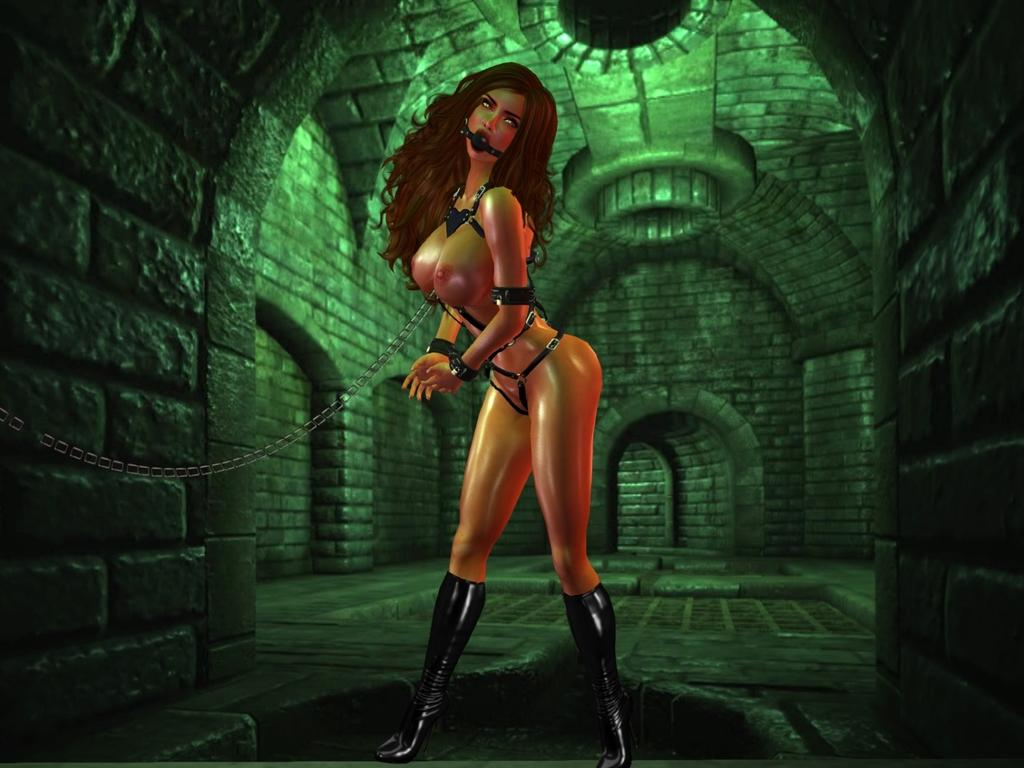Who is present in the image? There is a woman in the image. What is the woman's condition in the image? The woman is tied up with a chain in the image. Where is the woman located in the image? The woman is standing on the floor in the image. What can be seen in the background of the image? There are walls in the background of the image. Is there a tiger hiding in the recess of the wall in the image? There is no tiger or recess present in the image; it only features a woman tied up with a chain and walls in the background. 